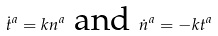<formula> <loc_0><loc_0><loc_500><loc_500>\dot { t } ^ { a } = k n ^ { a } \text { and } \dot { n } ^ { a } = - k t ^ { a }</formula> 